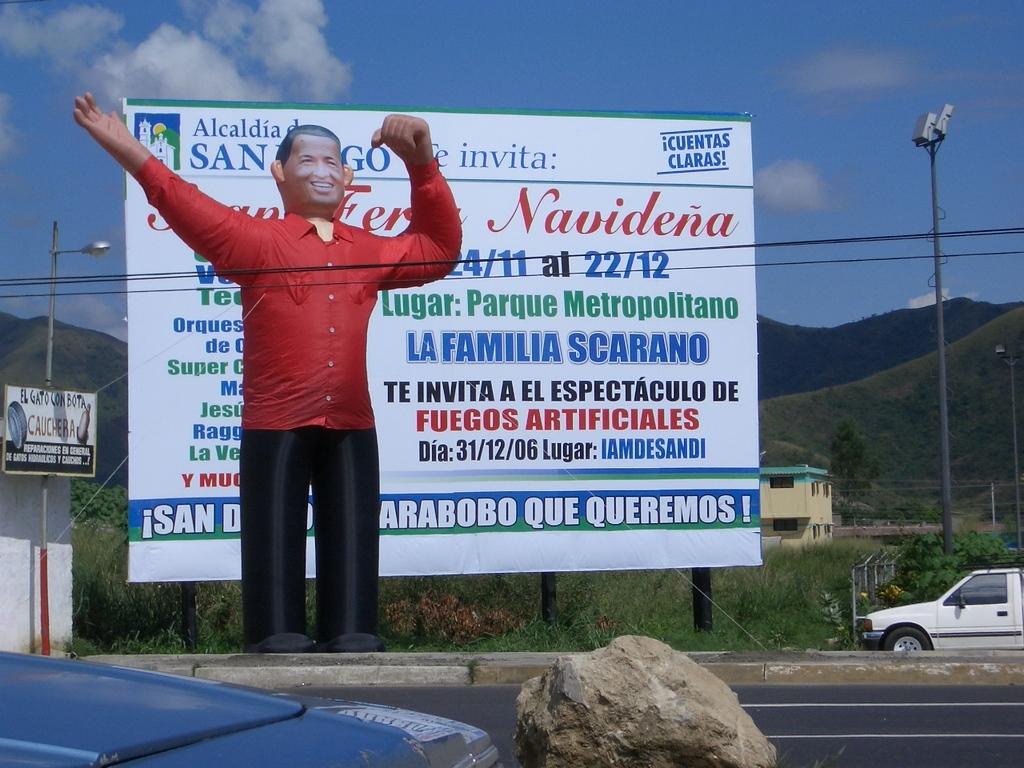What are the second pair of numbers after the word "at"?
Provide a succinct answer. 22/12. 